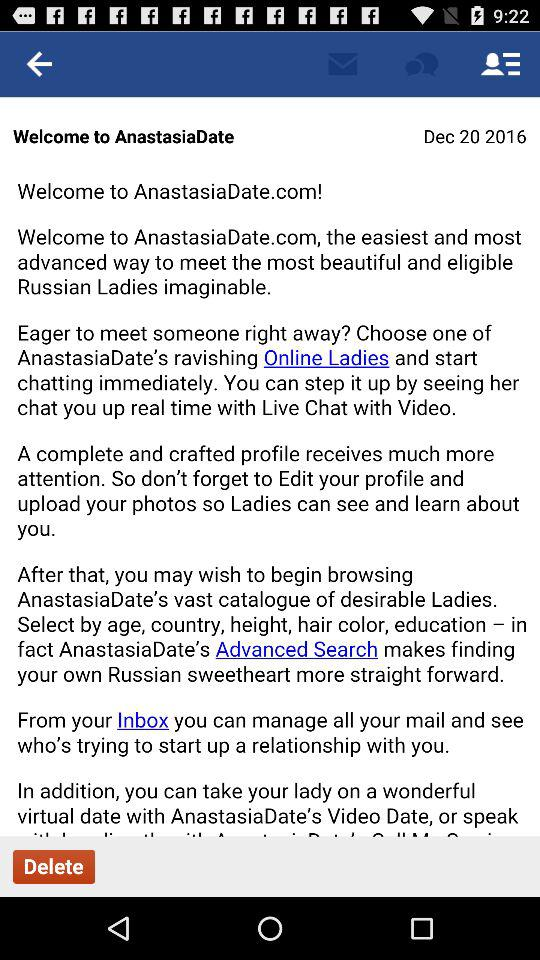What application is asking for permission? The application asking for permission is "Anastasia Date". 